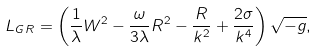<formula> <loc_0><loc_0><loc_500><loc_500>L _ { G R } = \left ( \frac { 1 } { \lambda } W ^ { 2 } - \frac { \omega } { 3 \lambda } R ^ { 2 } - \frac { R } { k ^ { 2 } } + \frac { 2 \sigma } { k ^ { 4 } } \right ) \sqrt { - g } ,</formula> 